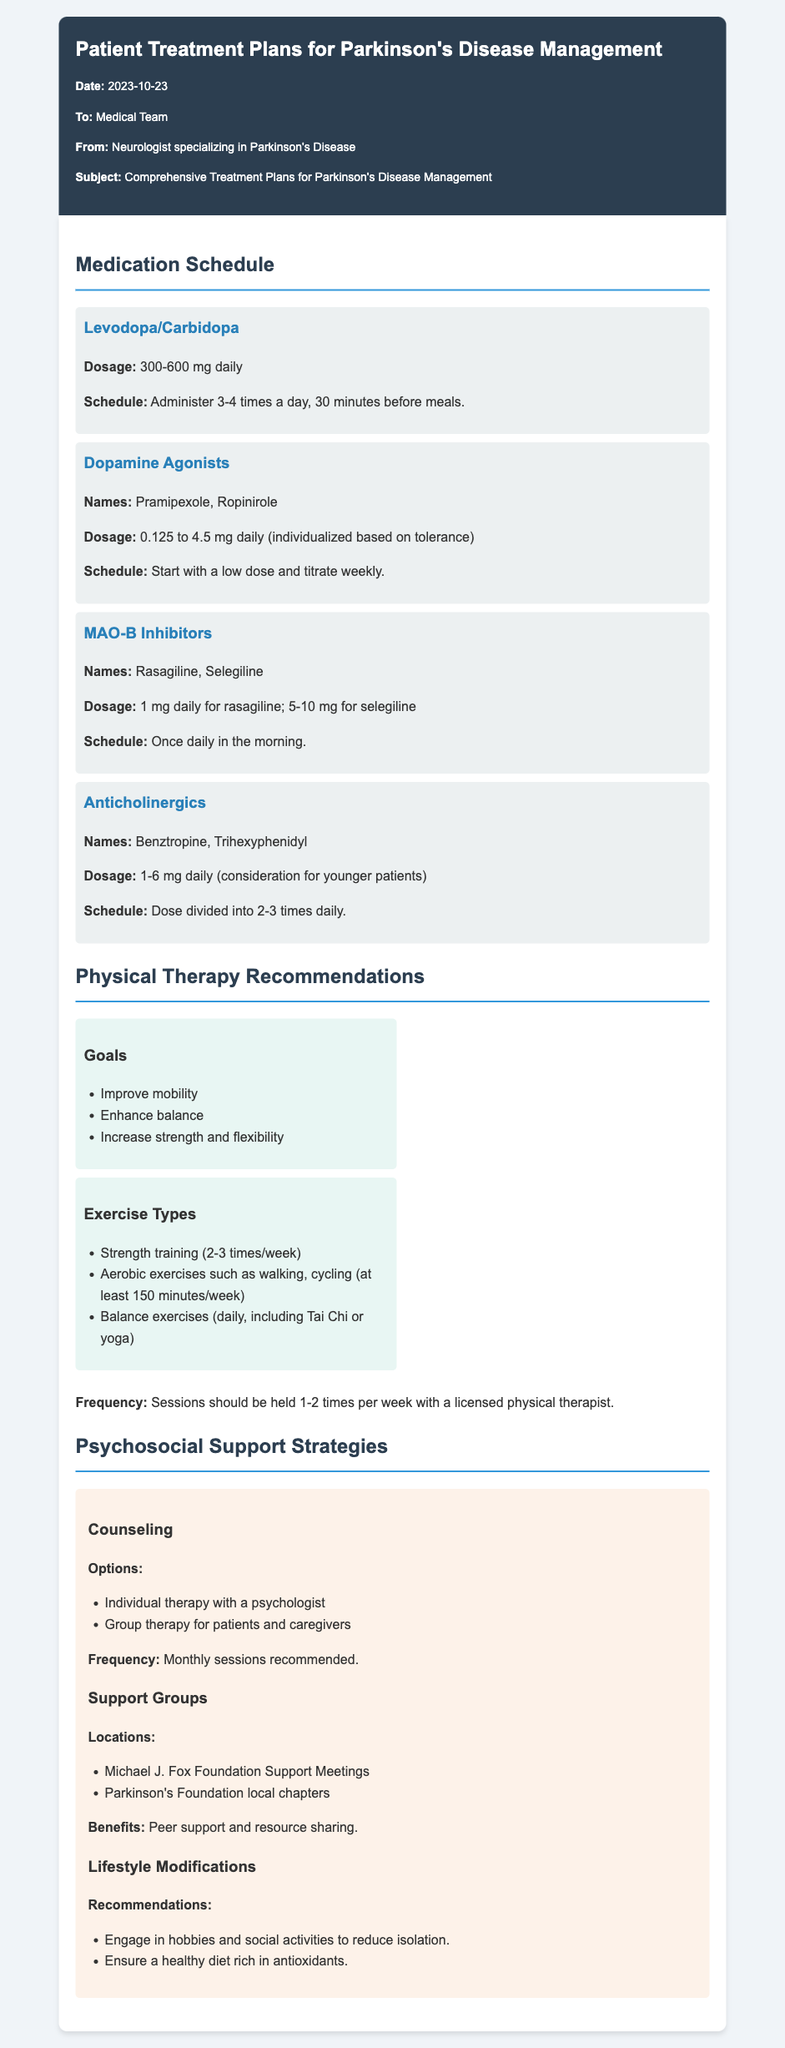What is the date of the memo? The date is mentioned in the meta-info section of the document.
Answer: 2023-10-23 What is the recommended daily dosage range for Levodopa/Carbidopa? The dosage for Levodopa/Carbidopa is specified in the medication schedule section.
Answer: 300-600 mg daily Which type of exercise is recommended to be performed daily? The document lists exercises in the physical therapy section, and this specific requirement is clearly stated.
Answer: Balance exercises What is the frequency of physical therapy sessions recommended? The frequency for physical therapy sessions is noted in the physical therapy recommendations section.
Answer: 1-2 times per week What are the names of two dopamine agonists mentioned? The names can be found in the medication schedule section under dopamine agonists.
Answer: Pramipexole, Ropinirole What types of counseling options are provided? The counseling options are listed in the psychosocial support strategies section.
Answer: Individual therapy, Group therapy What is the dosage of rasagiline indicated in the document? The dosage for rasagiline is mentioned in the medication schedule for MAO-B inhibitors.
Answer: 1 mg daily How often are the recommended counseling sessions? This information is found under the counseling section of psychosocial support.
Answer: Monthly sessions Which foundation hosts support group meetings? The name of the foundation is listed in the psychosocial support section.
Answer: Michael J. Fox Foundation 